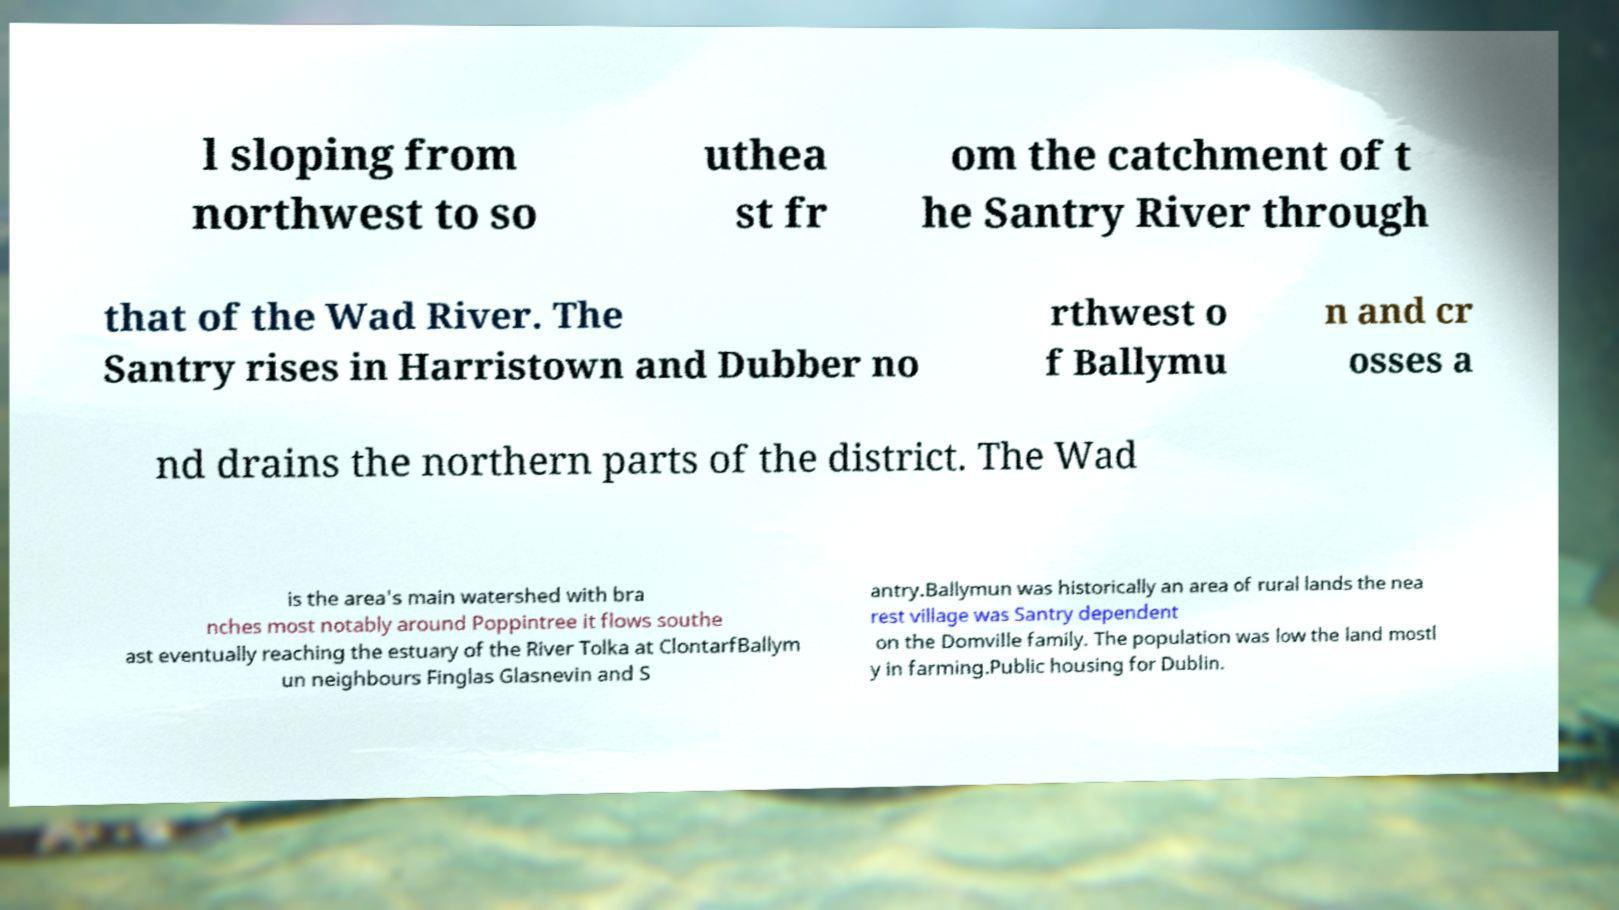Can you read and provide the text displayed in the image?This photo seems to have some interesting text. Can you extract and type it out for me? l sloping from northwest to so uthea st fr om the catchment of t he Santry River through that of the Wad River. The Santry rises in Harristown and Dubber no rthwest o f Ballymu n and cr osses a nd drains the northern parts of the district. The Wad is the area's main watershed with bra nches most notably around Poppintree it flows southe ast eventually reaching the estuary of the River Tolka at ClontarfBallym un neighbours Finglas Glasnevin and S antry.Ballymun was historically an area of rural lands the nea rest village was Santry dependent on the Domville family. The population was low the land mostl y in farming.Public housing for Dublin. 